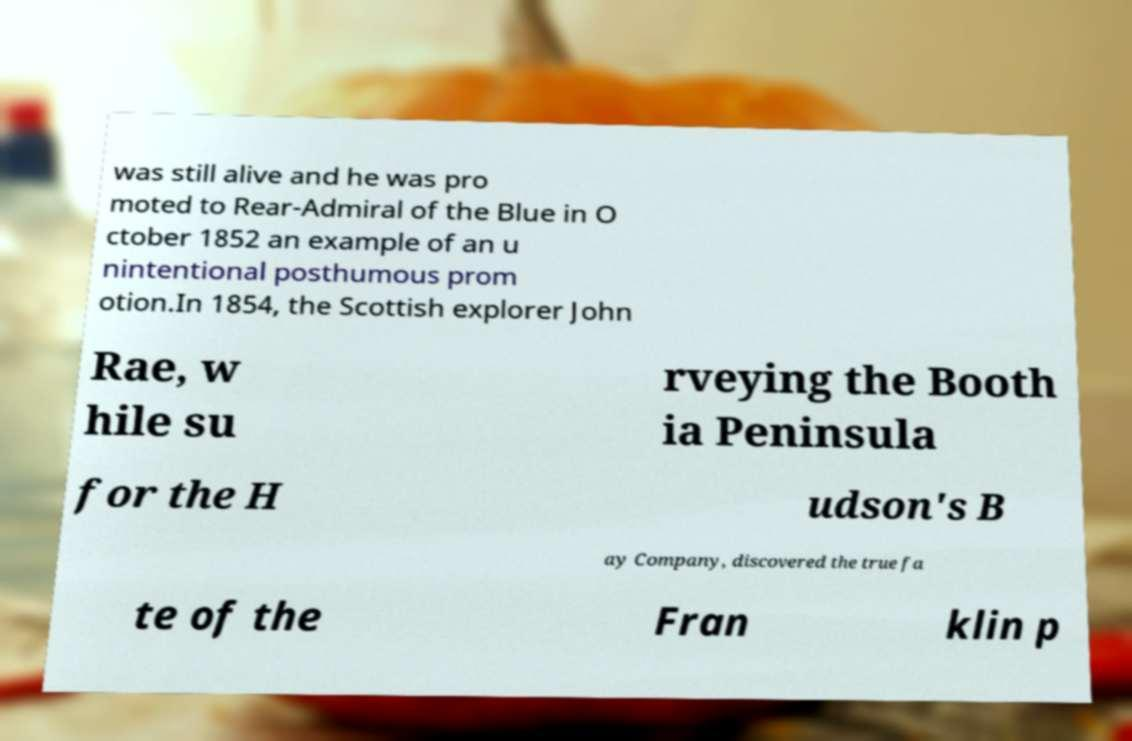What messages or text are displayed in this image? I need them in a readable, typed format. was still alive and he was pro moted to Rear-Admiral of the Blue in O ctober 1852 an example of an u nintentional posthumous prom otion.In 1854, the Scottish explorer John Rae, w hile su rveying the Booth ia Peninsula for the H udson's B ay Company, discovered the true fa te of the Fran klin p 